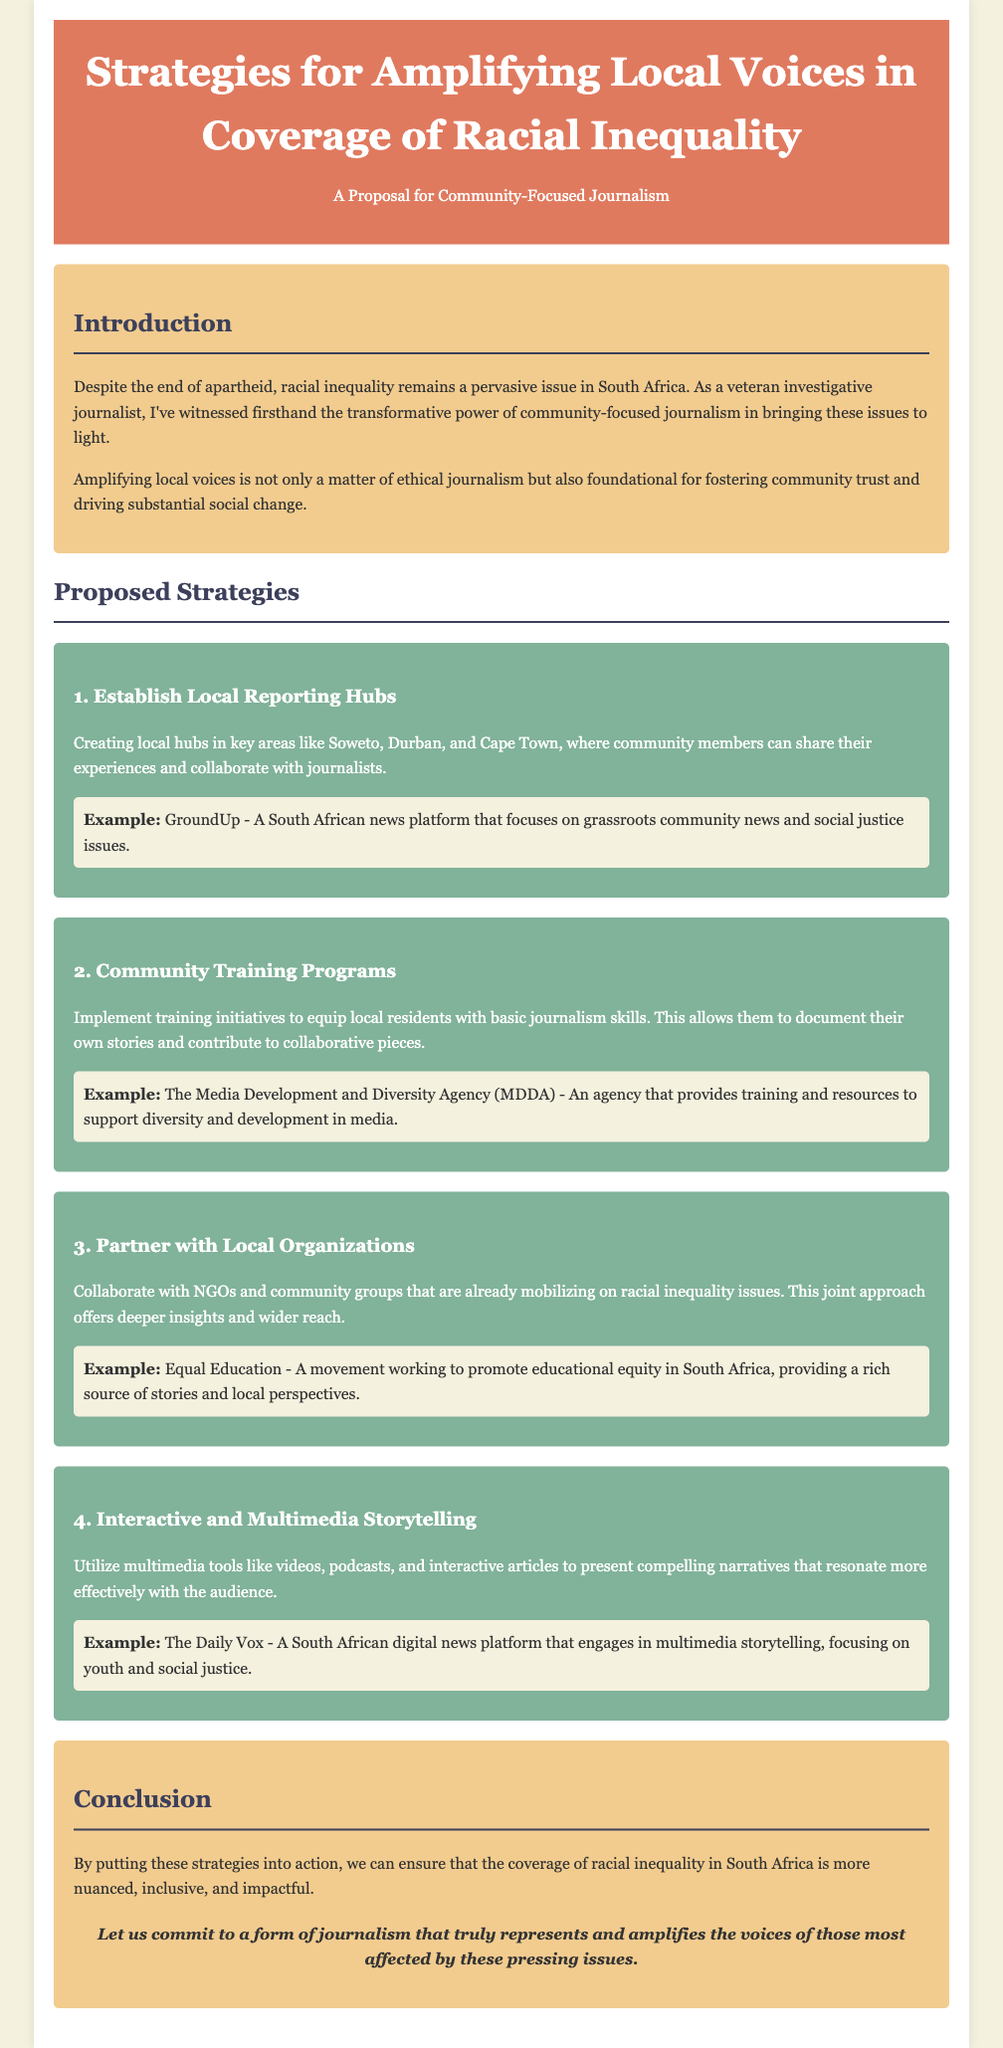What is the title of the proposal? The title of the proposal is listed in the header section of the document.
Answer: Strategies for Amplifying Local Voices in Coverage of Racial Inequality What are the first two proposed strategies? The proposed strategies are listed sequentially under the "Proposed Strategies" section.
Answer: Establish Local Reporting Hubs, Community Training Programs What example is provided for interactive and multimedia storytelling? The example for this strategy is found in the description of the fourth proposed strategy.
Answer: The Daily Vox How many proposed strategies are outlined in the document? This information can be counted in the Proposed Strategies section.
Answer: Four What is the main focus of the proposal? The focus of the proposal can be found in the introduction and is central to the document's purpose.
Answer: Community-Focused Journalism What organization provides training and resources for diversity in media? The organization is mentioned as part of the second proposed strategy.
Answer: Media Development and Diversity Agency (MDDA) What city is mentioned as a location for establishing local reporting hubs? The city is specifically pointed out in the first proposed strategy.
Answer: Cape Town What color scheme is used in the document's background? The color scheme is described in the styling sections of the HTML code but is visible in the rendered document.
Answer: F4F1DE 